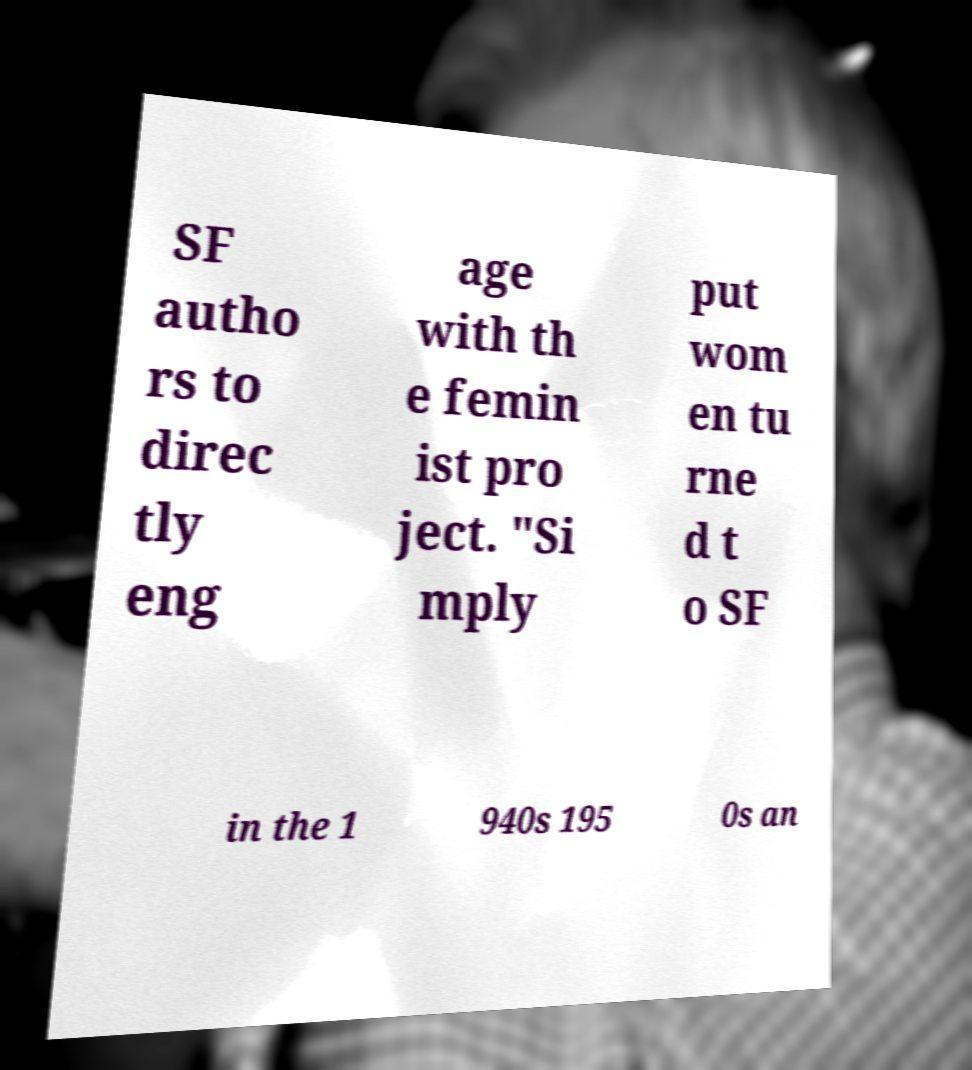Please identify and transcribe the text found in this image. SF autho rs to direc tly eng age with th e femin ist pro ject. "Si mply put wom en tu rne d t o SF in the 1 940s 195 0s an 